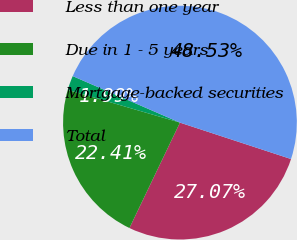Convert chart. <chart><loc_0><loc_0><loc_500><loc_500><pie_chart><fcel>Less than one year<fcel>Due in 1 - 5 years<fcel>Mortgage-backed securities<fcel>Total<nl><fcel>27.07%<fcel>22.41%<fcel>1.99%<fcel>48.53%<nl></chart> 